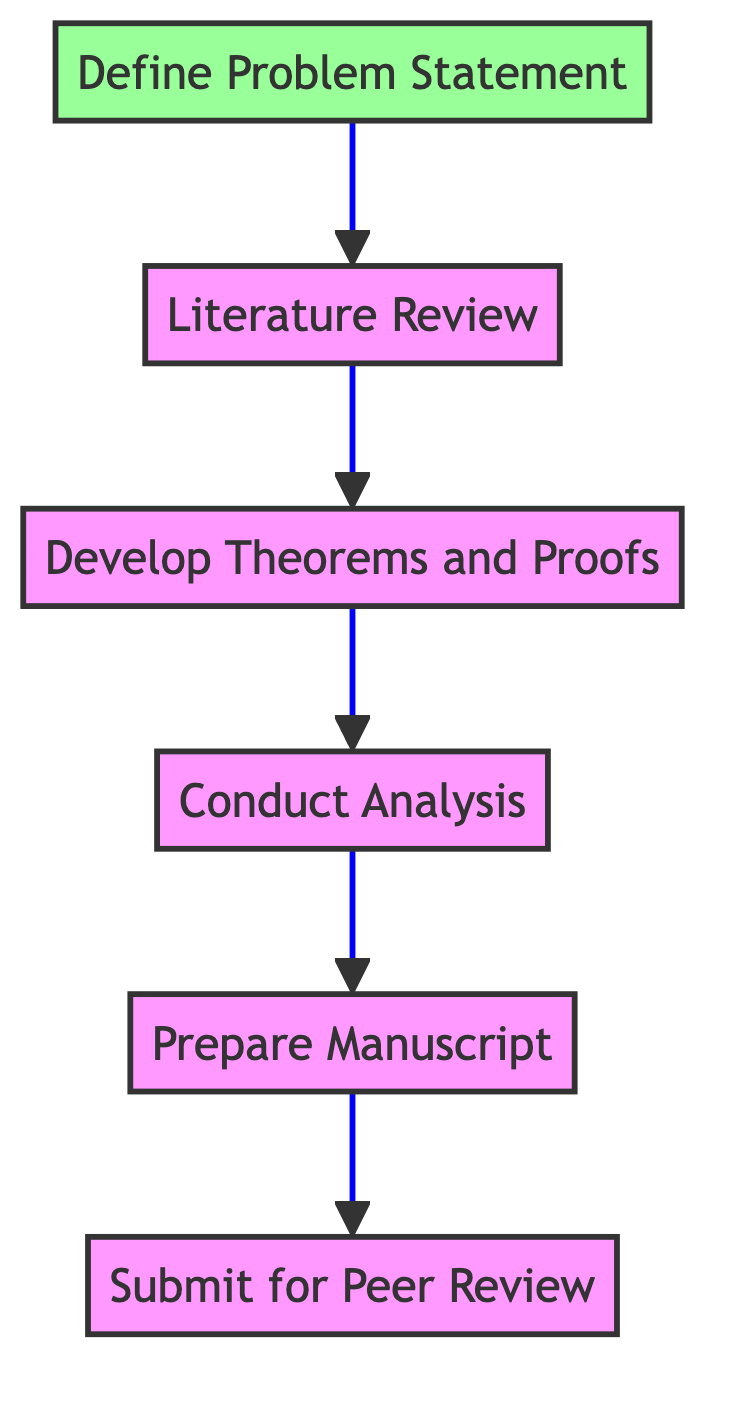What is the first step in the process? The diagram shows that the first step in the process is to "Define Problem Statement," as it is the bottom node that leads to all subsequent steps.
Answer: Define Problem Statement How many nodes are there in this flow chart? The flow chart contains a total of six nodes, which represent the steps in publishing a mathematical research paper.
Answer: Six What is the last step before submitting the paper? The last step before submitting the paper is "Prepare Manuscript," which directly leads to the submission for peer review.
Answer: Prepare Manuscript Which step directly follows the literature review? The step that directly follows "Literature Review" is "Develop Theorems and Proofs," as indicated by the arrow leading from literature review to theorems development.
Answer: Develop Theorems and Proofs If the problem statement is defined, what is the next action to take? Once the problem statement is defined, the next action to take is to conduct a "Literature Review," as this is the immediate step that follows in the diagram.
Answer: Literature Review Is there any step that has no dependencies? Yes, the "Define Problem Statement" is the only step in the flow chart that has no dependencies, meaning it does not require any previous steps to be completed first.
Answer: Yes What sequence of steps is required after conducting analysis? After conducting analysis, the sequence of steps required is to "Prepare Manuscript" followed by "Submit for Peer Review." This indicates the workflow directly transitions from conducting analysis to preparing the manuscript.
Answer: Prepare Manuscript, Submit for Peer Review Which step serves as the basis for conducting the analysis? The basis for conducting the analysis is "Develop Theorems and Proofs," as this step must be completed before analysis can occur.
Answer: Develop Theorems and Proofs 